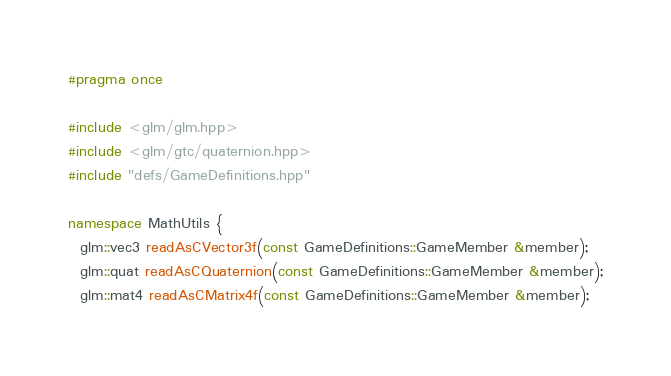<code> <loc_0><loc_0><loc_500><loc_500><_C++_>#pragma once

#include <glm/glm.hpp>
#include <glm/gtc/quaternion.hpp>
#include "defs/GameDefinitions.hpp"

namespace MathUtils {
  glm::vec3 readAsCVector3f(const GameDefinitions::GameMember &member);
  glm::quat readAsCQuaternion(const GameDefinitions::GameMember &member);
  glm::mat4 readAsCMatrix4f(const GameDefinitions::GameMember &member);</code> 